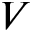<formula> <loc_0><loc_0><loc_500><loc_500>V</formula> 